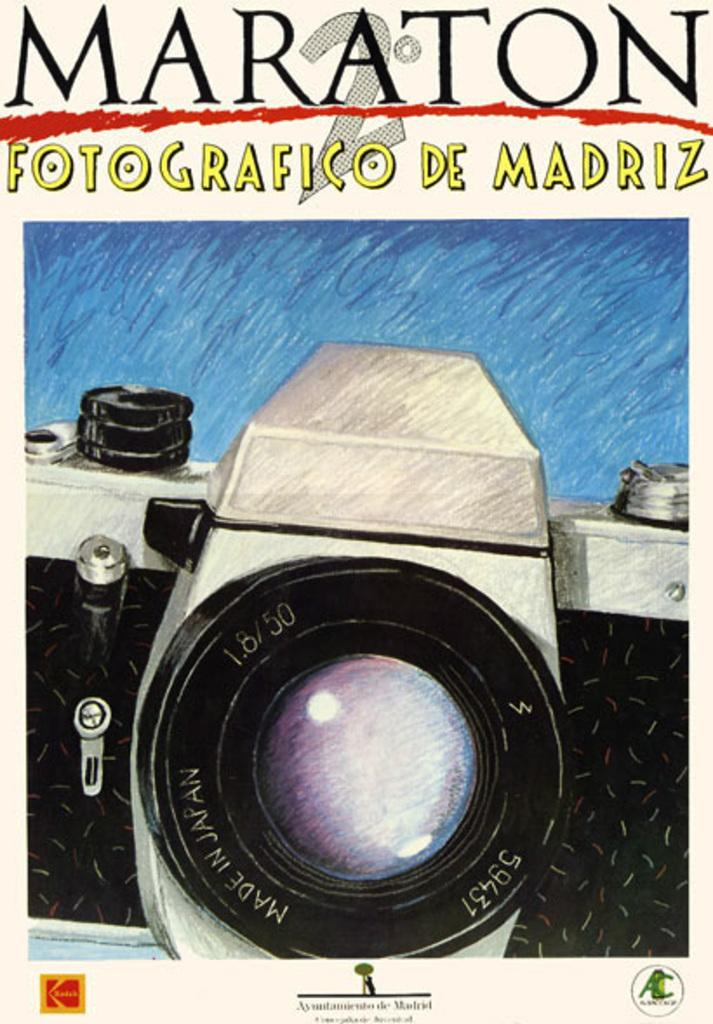What is featured in the image? There is a poster and a camera in the image. What can be found on the poster? The poster contains text and logos. What type of pleasure can be seen enjoying a journey in the image? There is no pleasure or journey depicted in the image; it features a poster and a camera. What type of tail is attached to the camera in the image? There is no tail attached to the camera in the image; it is a standalone device. 